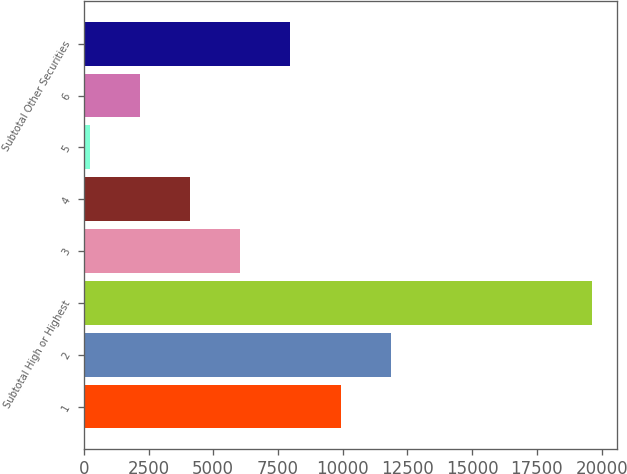<chart> <loc_0><loc_0><loc_500><loc_500><bar_chart><fcel>1<fcel>2<fcel>Subtotal High or Highest<fcel>3<fcel>4<fcel>5<fcel>6<fcel>Subtotal Other Securities<nl><fcel>9920<fcel>11858.8<fcel>19614<fcel>6042.4<fcel>4103.6<fcel>226<fcel>2164.8<fcel>7981.2<nl></chart> 